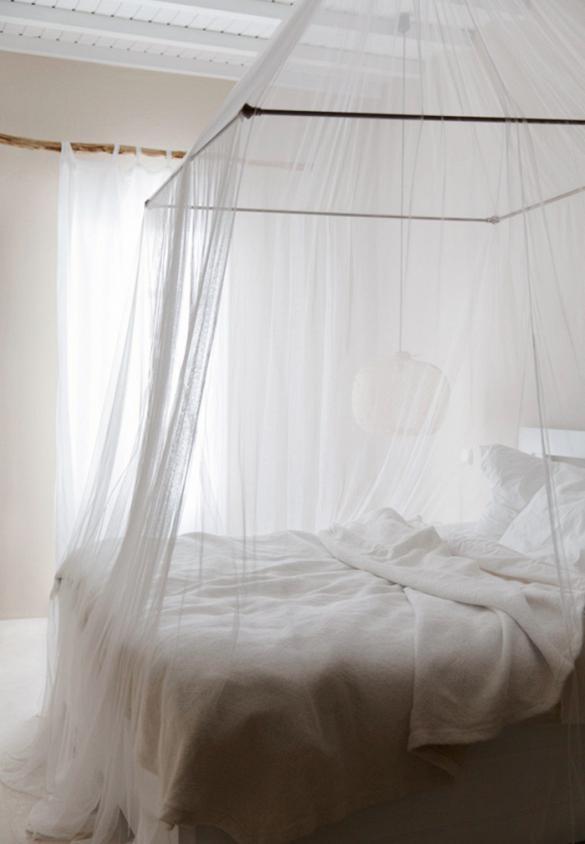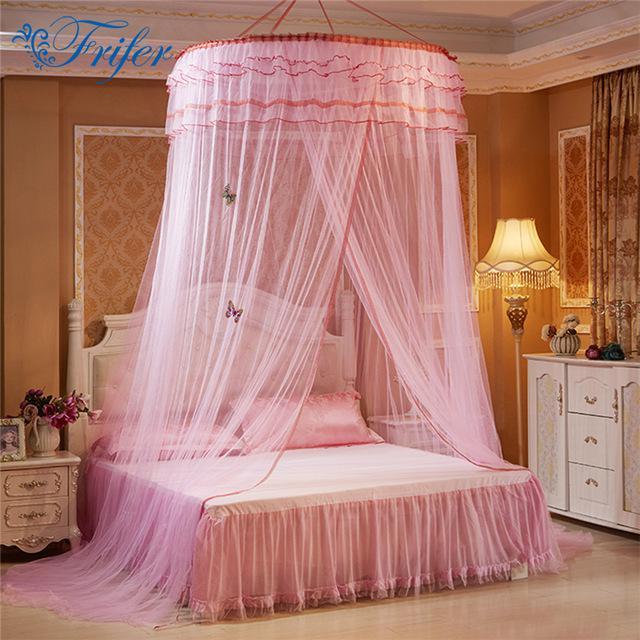The first image is the image on the left, the second image is the image on the right. Analyze the images presented: Is the assertion "The left bed is covered by a square drape, the right bed by a round drape." valid? Answer yes or no. Yes. The first image is the image on the left, the second image is the image on the right. For the images shown, is this caption "All curtains displayed are pink or red and hung from a circular shaped rod directly above the bed." true? Answer yes or no. No. 